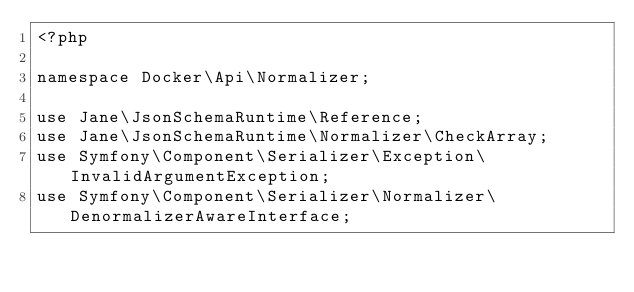<code> <loc_0><loc_0><loc_500><loc_500><_PHP_><?php

namespace Docker\Api\Normalizer;

use Jane\JsonSchemaRuntime\Reference;
use Jane\JsonSchemaRuntime\Normalizer\CheckArray;
use Symfony\Component\Serializer\Exception\InvalidArgumentException;
use Symfony\Component\Serializer\Normalizer\DenormalizerAwareInterface;</code> 